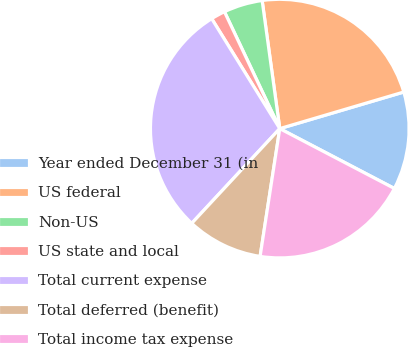Convert chart to OTSL. <chart><loc_0><loc_0><loc_500><loc_500><pie_chart><fcel>Year ended December 31 (in<fcel>US federal<fcel>Non-US<fcel>US state and local<fcel>Total current expense<fcel>Total deferred (benefit)<fcel>Total income tax expense<nl><fcel>12.23%<fcel>22.61%<fcel>4.86%<fcel>1.79%<fcel>29.26%<fcel>9.49%<fcel>19.77%<nl></chart> 